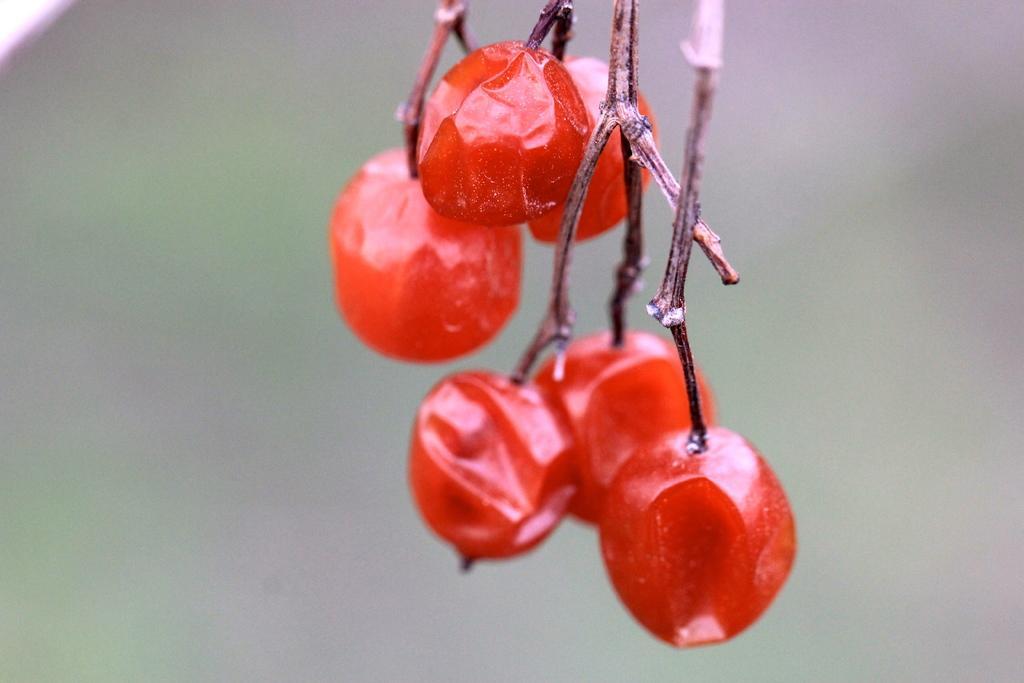In one or two sentences, can you explain what this image depicts? In this image we can see the fruits. The background of the image is blurred. 